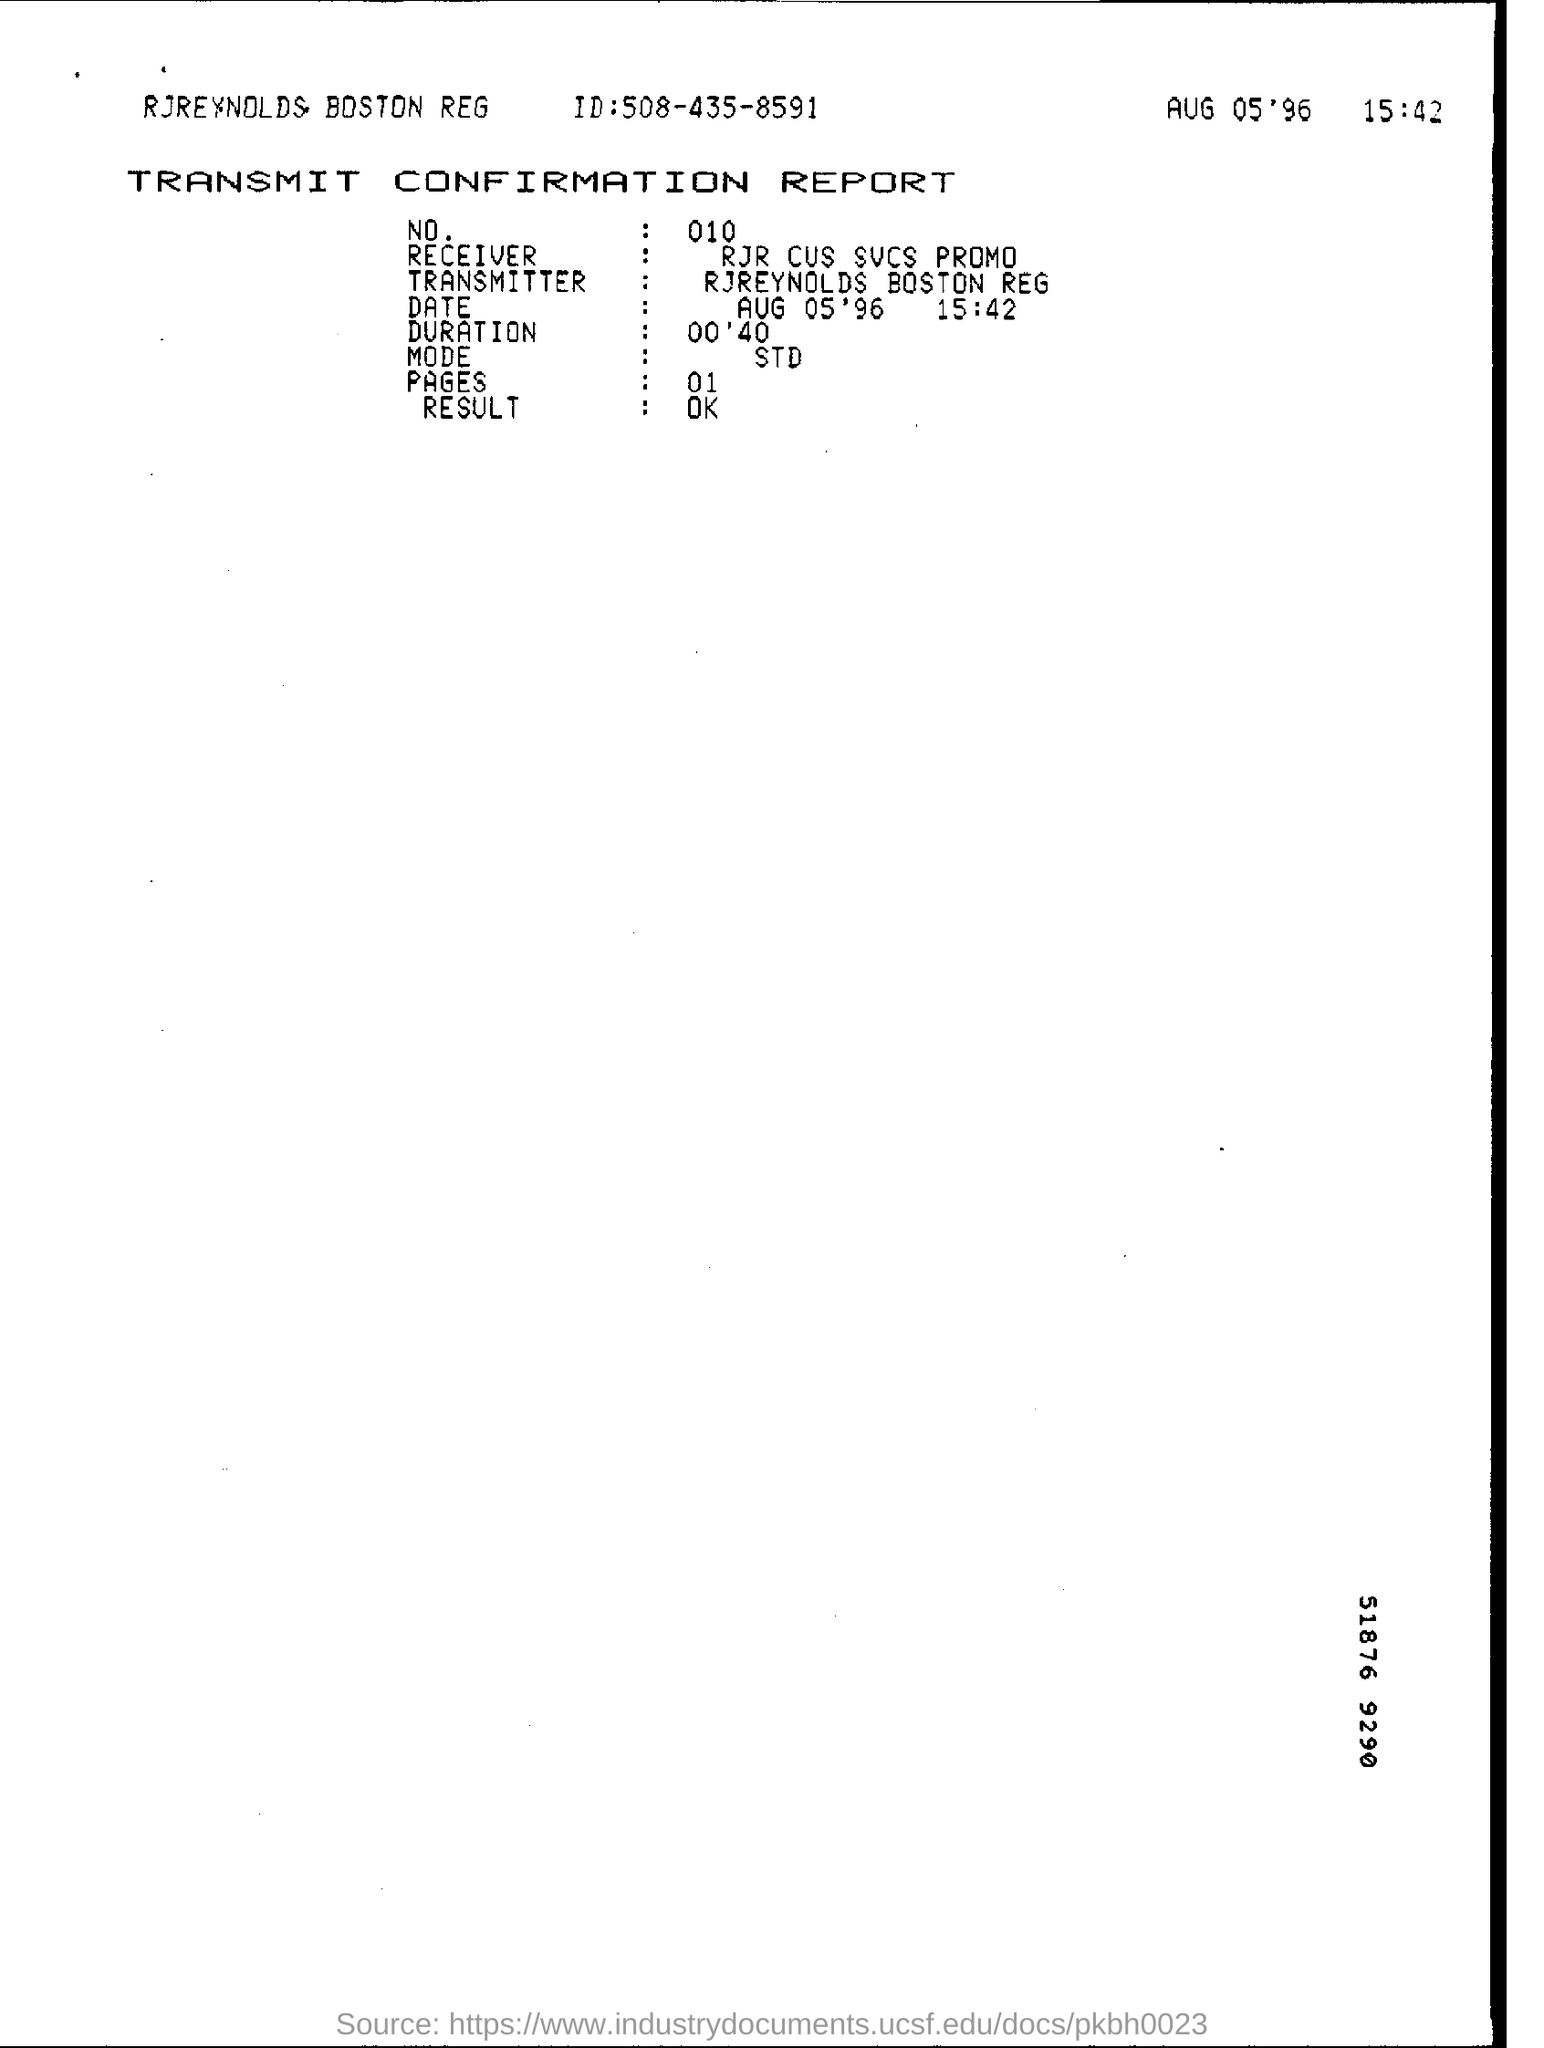Mention a couple of crucial points in this snapshot. The report is called the 'TRANSMIT CONFIRMATION REPORT.' There are one or more pages in the report. The name of the receiver for the promotion related to the services provided by RJR CUS for cus customers is [insert name here]. The result is "OK. The identity of the transmitter is unknown. It is either RJ Reynolds, Boston Reed, or a company with the same name as the recipient. 